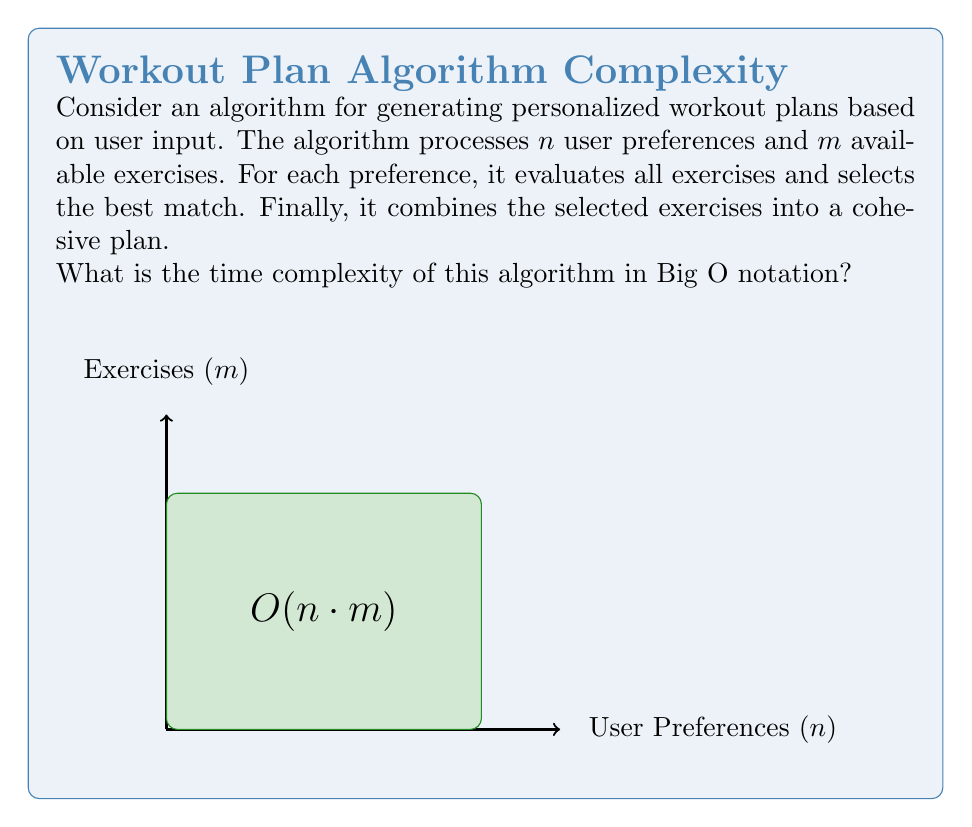Solve this math problem. To analyze the time complexity of this algorithm, let's break it down step by step:

1. The algorithm processes $n$ user preferences.

2. For each preference, it evaluates all $m$ available exercises.
   This creates a nested loop structure:
   ```
   for each preference (n times):
       for each exercise (m times):
           evaluate exercise
   ```

3. The evaluation of each exercise for a preference is assumed to be a constant time operation, $O(1)$.

4. The nested loop structure results in $n * m$ operations.

5. After selecting exercises, combining them into a plan is assumed to be linear in the number of preferences, $O(n)$.

6. The dominant term in the time complexity is the nested loop, $O(n * m)$.

7. The final step of combining exercises doesn't change the overall complexity class.

Therefore, the overall time complexity of the algorithm is $O(n * m)$, where $n$ is the number of user preferences and $m$ is the number of available exercises.
Answer: $O(n * m)$ 